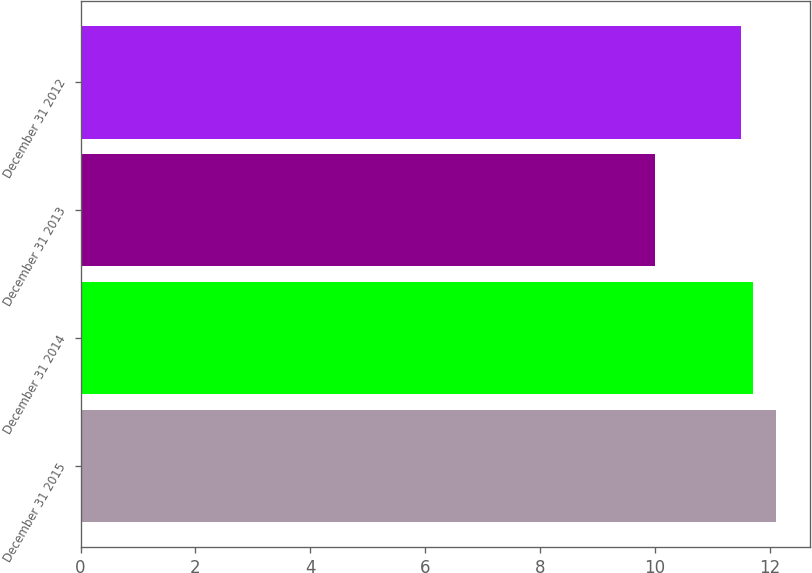Convert chart to OTSL. <chart><loc_0><loc_0><loc_500><loc_500><bar_chart><fcel>December 31 2015<fcel>December 31 2014<fcel>December 31 2013<fcel>December 31 2012<nl><fcel>12.1<fcel>11.71<fcel>10<fcel>11.5<nl></chart> 